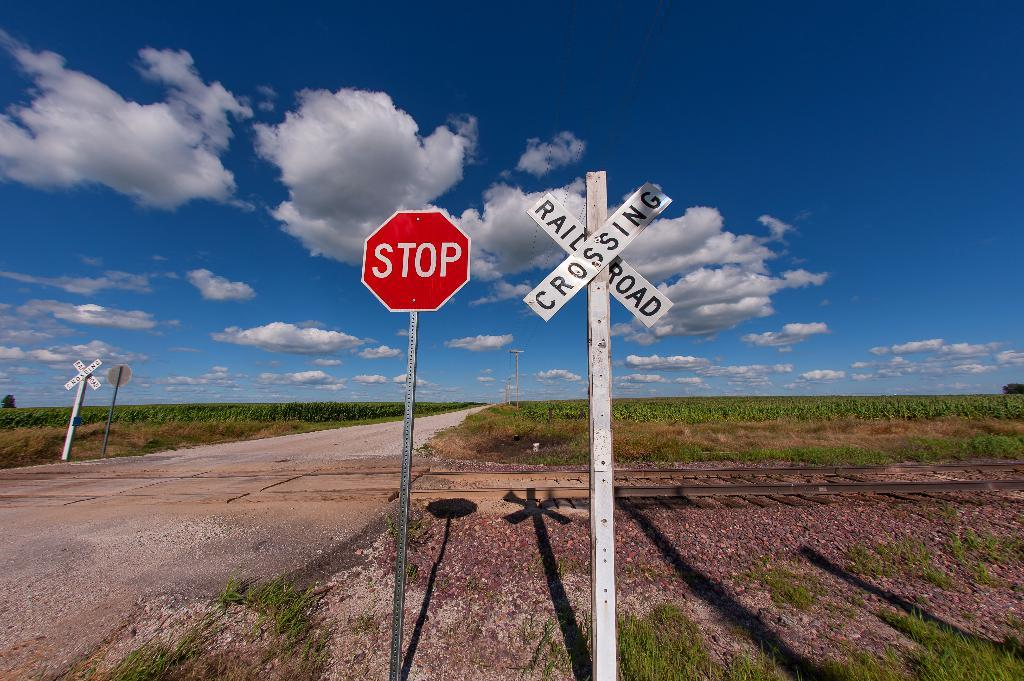<image>
Render a clear and concise summary of the photo. two signs, one says STOP and the other RAILROAD CROSSING on a long rural roadside. 